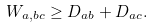Convert formula to latex. <formula><loc_0><loc_0><loc_500><loc_500>W _ { a , b c } \geq D _ { a b } + D _ { a c } .</formula> 